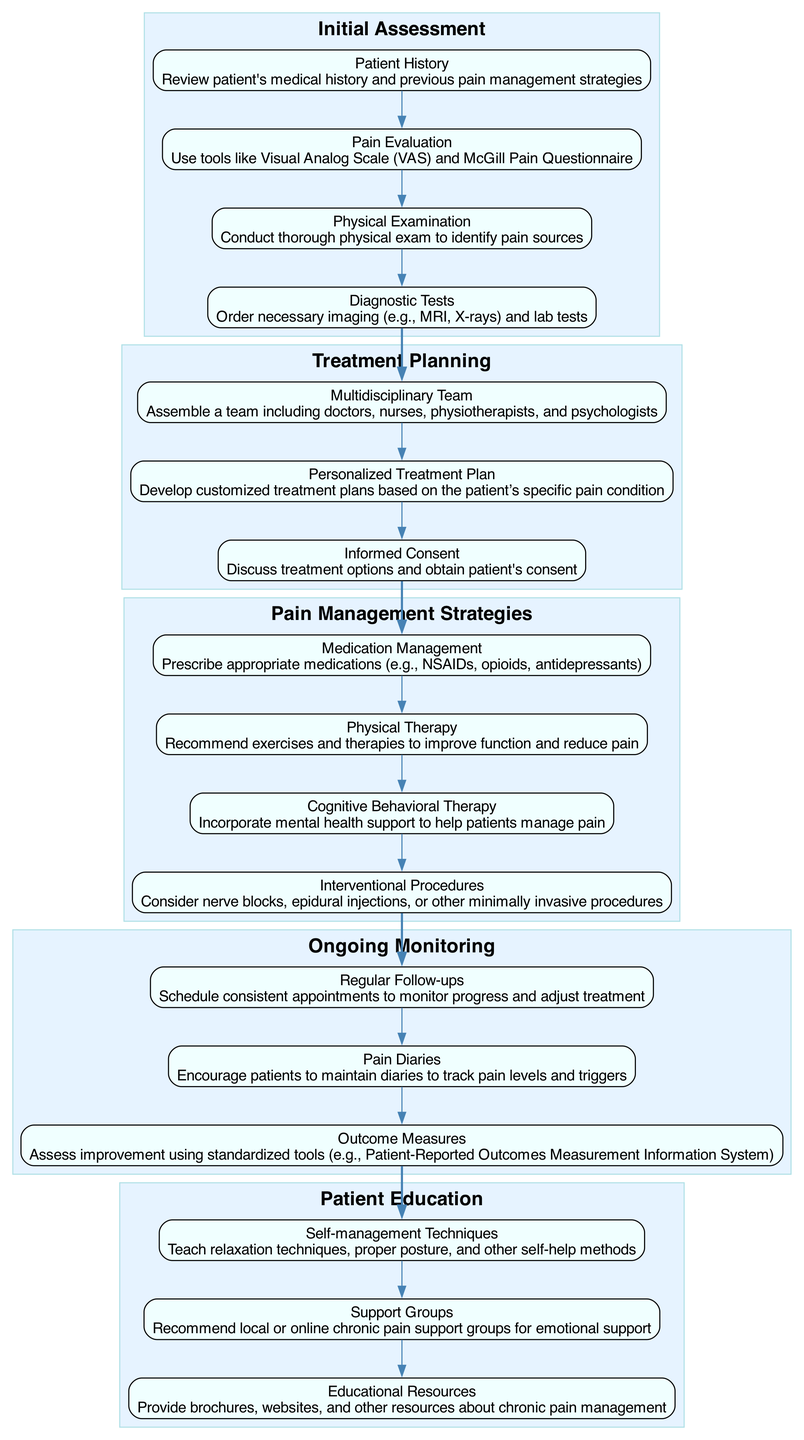What are the four elements in the Initial Assessment phase? In the Initial Assessment phase, there are four identified elements: Patient History, Pain Evaluation, Physical Examination, and Diagnostic Tests.
Answer: Patient History, Pain Evaluation, Physical Examination, Diagnostic Tests How many phases are there in the clinical pathway? The clinical pathway consists of five distinct phases: Initial Assessment, Treatment Planning, Pain Management Strategies, Ongoing Monitoring, and Patient Education.
Answer: 5 What is the first step in the Treatment Planning phase? The first step in the Treatment Planning phase is the assembly of a Multidisciplinary Team, which includes various healthcare professionals.
Answer: Multidisciplinary Team Which pain management strategy is incorporated for mental health support? Cognitive Behavioral Therapy is the pain management strategy that incorporates mental health support to assist patients in managing their pain.
Answer: Cognitive Behavioral Therapy What details are reviewed during the Patient History assessment? During the Patient History assessment, the patient's medical history and previous pain management strategies are reviewed to inform further treatment decisions.
Answer: Review patient's medical history and previous pain management strategies Which element connects the Initial Assessment to the Treatment Planning phase? The edge connecting the Initial Assessment phase to the Treatment Planning phase is based on the finalized results from the Diagnostic Tests, leading to the establishment of a Multidisciplinary Team for planning.
Answer: Diagnostic Tests What type of measurements are used to assess improvement in Ongoing Monitoring? The assessment of improvement in Ongoing Monitoring utilizes standardized tools, specifically the Patient-Reported Outcomes Measurement Information System, to gauge patient progress.
Answer: Patient-Reported Outcomes Measurement Information System What is provided to patients as part of the Patient Education phase? In the Patient Education phase, patients receive Educational Resources such as brochures, websites, and other informational materials about chronic pain management.
Answer: Educational Resources 